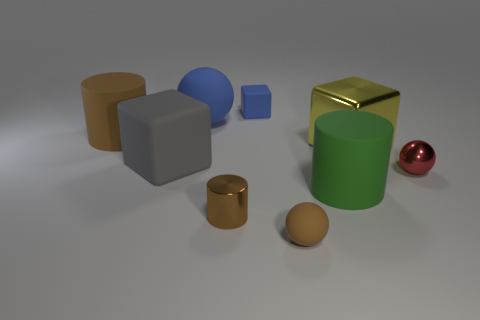Add 1 big purple rubber blocks. How many objects exist? 10 Subtract 1 cylinders. How many cylinders are left? 2 Subtract all tiny blocks. How many blocks are left? 2 Subtract all spheres. How many objects are left? 6 Subtract all brown cylinders. How many cylinders are left? 1 Subtract all red cylinders. How many cyan spheres are left? 0 Subtract all gray blocks. Subtract all blue matte blocks. How many objects are left? 7 Add 4 large shiny blocks. How many large shiny blocks are left? 5 Add 1 brown rubber balls. How many brown rubber balls exist? 2 Subtract 0 cyan balls. How many objects are left? 9 